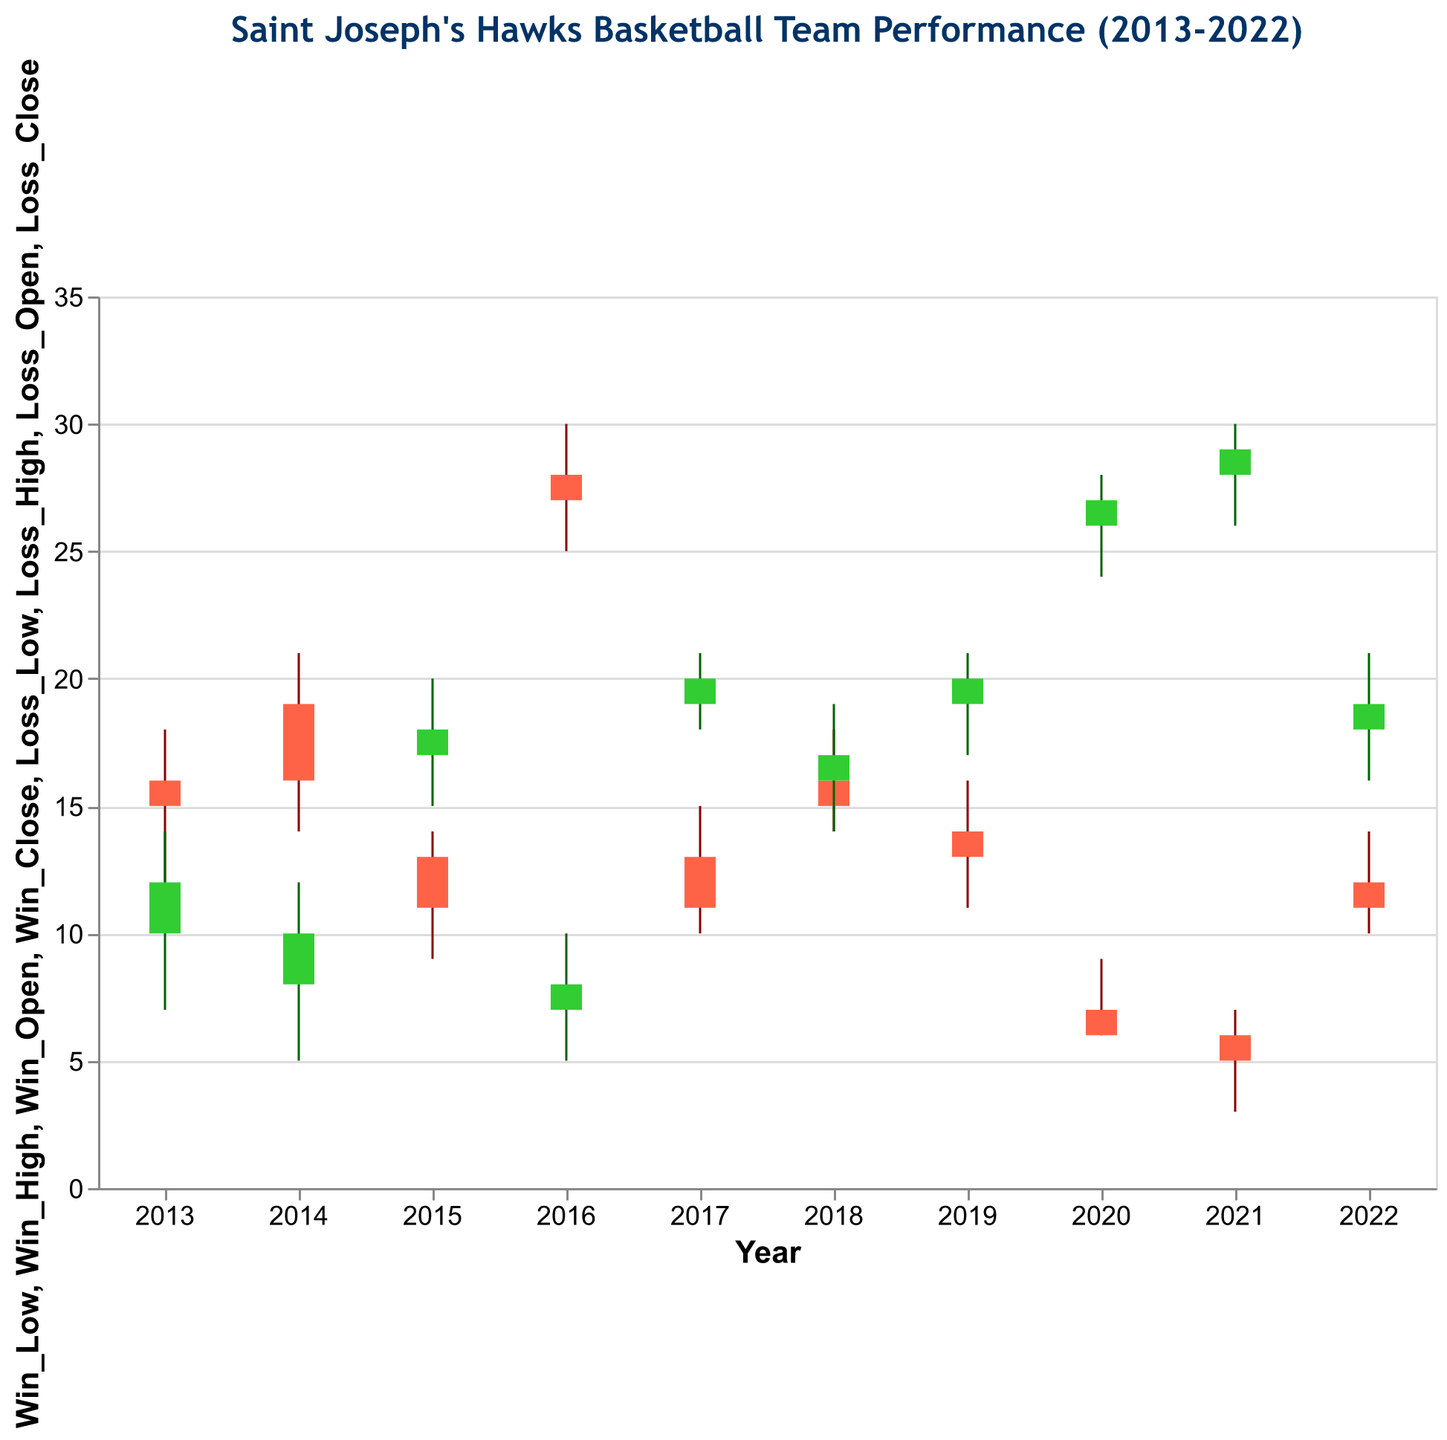What's the title of the figure? The title is at the top of the figure and describes what the chart is about.
Answer: Saint Joseph's Hawks Basketball Team Performance (2013-2022) How many years of data are represented in the figure? Counting the distinct years on the x-axis from 2013 to 2022 gives us the total number of years.
Answer: 10 Which year had the highest winning rate? In 2016, the winning values range from 25 to 30, which is the highest range among all the years.
Answer: 2016 How did the losses change from 2020 to 2021? For 2020, losses closed at 27 and for 2021, losses closed at 29. So, there was an increase in losses.
Answer: Increased What is the minimum number of wins in 2014? In 2014, the lowest win value (Win_Low) recorded was 14.
Answer: 14 Which year had the highest variance in wins, and what is that variance? Calculating variance involves looking at the difference between Win_High and Win_Low. The year 2016 had the highest variance (30 - 25 = 5).
Answer: 2016, 5 During which years did Saint Joseph's Hawks have more losses than wins? Comparing Win_Close and Loss_Close for each year shows that in 2015, 2017, 2018, 2019, 2020, 2021, and 2022, losses were greater than wins.
Answer: 2015, 2017, 2018, 2019, 2020, 2021, 2022 In which year were the losses consistently low? In 2013, the loss values ranged from 7 to 14, which is lower compared to other years where losses were much higher.
Answer: 2013 What is the total number of wins recorded in 2022 including the Open, High, Low, and Close values? Adding up the values for 2022: Win_Open (11), Win_High (14), Win_Low (10), Win_Close (12) results in 11 + 14 + 10 + 12 = 47.
Answer: 47 